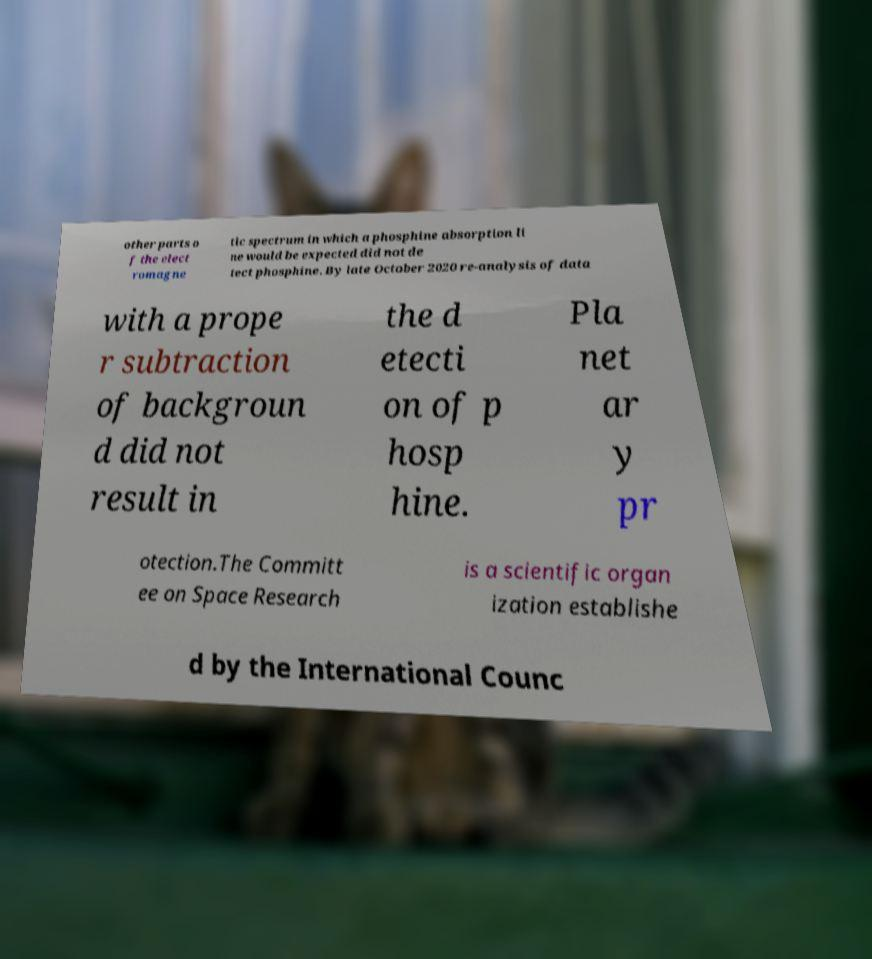There's text embedded in this image that I need extracted. Can you transcribe it verbatim? other parts o f the elect romagne tic spectrum in which a phosphine absorption li ne would be expected did not de tect phosphine. By late October 2020 re-analysis of data with a prope r subtraction of backgroun d did not result in the d etecti on of p hosp hine. Pla net ar y pr otection.The Committ ee on Space Research is a scientific organ ization establishe d by the International Counc 